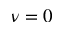Convert formula to latex. <formula><loc_0><loc_0><loc_500><loc_500>\nu = 0</formula> 